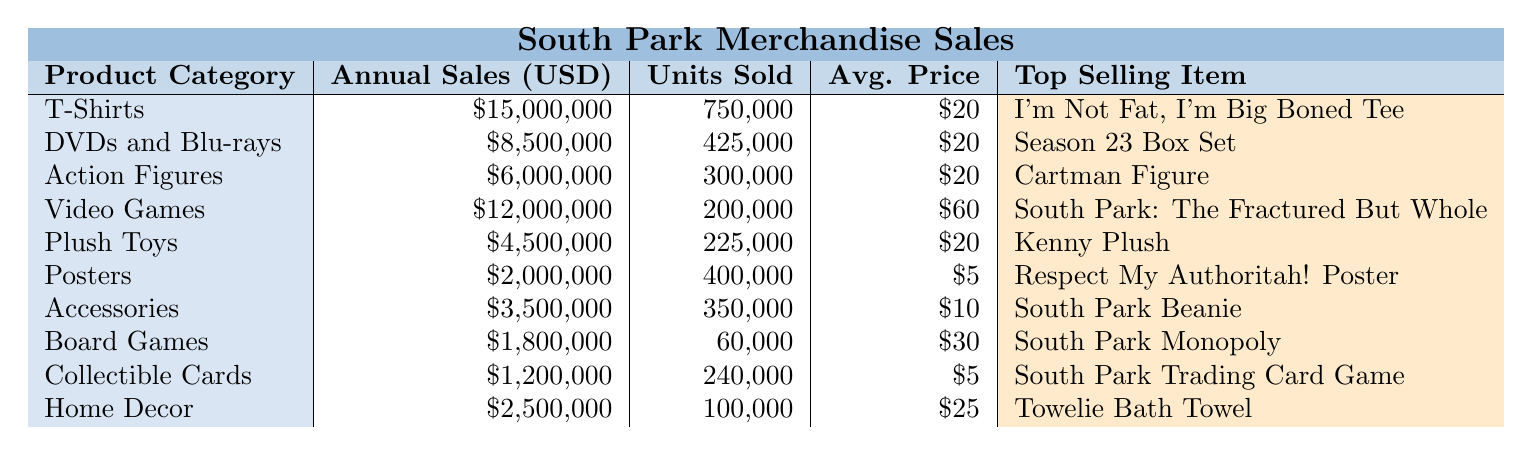What is the top-selling item in the T-Shirts category? The T-Shirts category lists "I'm Not Fat, I'm Big Boned Tee" as the top-selling item.
Answer: I'm Not Fat, I'm Big Boned Tee How much do DVDs and Blu-rays generate in annual sales? The table shows that the annual sales for DVDs and Blu-rays are $8,500,000.
Answer: $8,500,000 What is the average price of Action Figures? The average price listed for Action Figures is $20.
Answer: $20 Which product category has the highest annual sales? T-Shirts have the highest annual sales at $15,000,000.
Answer: T-Shirts What is the total annual sales for Plush Toys and Home Decor combined? Adding the annual sales for Plush Toys ($4,500,000) and Home Decor ($2,500,000) gives a total of $7,000,000. ($4,500,000 + $2,500,000 = $7,000,000)
Answer: $7,000,000 How many Units Sold were for Board Games? The table indicates that Board Games sold 60,000 units.
Answer: 60,000 Is the average price of Collectible Cards higher than $5? The average price of Collectible Cards is $5, which is not higher than $5.
Answer: No Which product category has the lowest annual sales, and what is the amount? The lowest annual sales are for Board Games at $1,800,000.
Answer: Board Games, $1,800,000 What percentage of total sales does the T-Shirts category represent? Total annual sales across all categories is $61,500,000. T-Shirts make up $15,000,000 of this, which is approximately 24.4%. (15,000,000 / 61,500,000 * 100 ≈ 24.4)
Answer: Approximately 24.4% What is the average price across all product categories? The average price can be calculated by summing the average prices ($20 + $20 + $20 + $60 + $20 + $5 + $10 + $30 + $5 + $25 = $225) and dividing by the number of categories (10), yielding an average price of $22.50. (225 / 10 = 22.5)
Answer: $22.50 